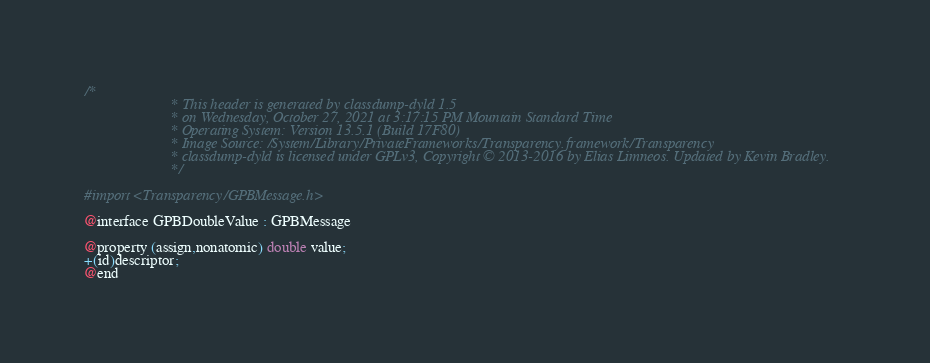<code> <loc_0><loc_0><loc_500><loc_500><_C_>/*
                       * This header is generated by classdump-dyld 1.5
                       * on Wednesday, October 27, 2021 at 3:17:15 PM Mountain Standard Time
                       * Operating System: Version 13.5.1 (Build 17F80)
                       * Image Source: /System/Library/PrivateFrameworks/Transparency.framework/Transparency
                       * classdump-dyld is licensed under GPLv3, Copyright © 2013-2016 by Elias Limneos. Updated by Kevin Bradley.
                       */

#import <Transparency/GPBMessage.h>

@interface GPBDoubleValue : GPBMessage

@property (assign,nonatomic) double value; 
+(id)descriptor;
@end

</code> 